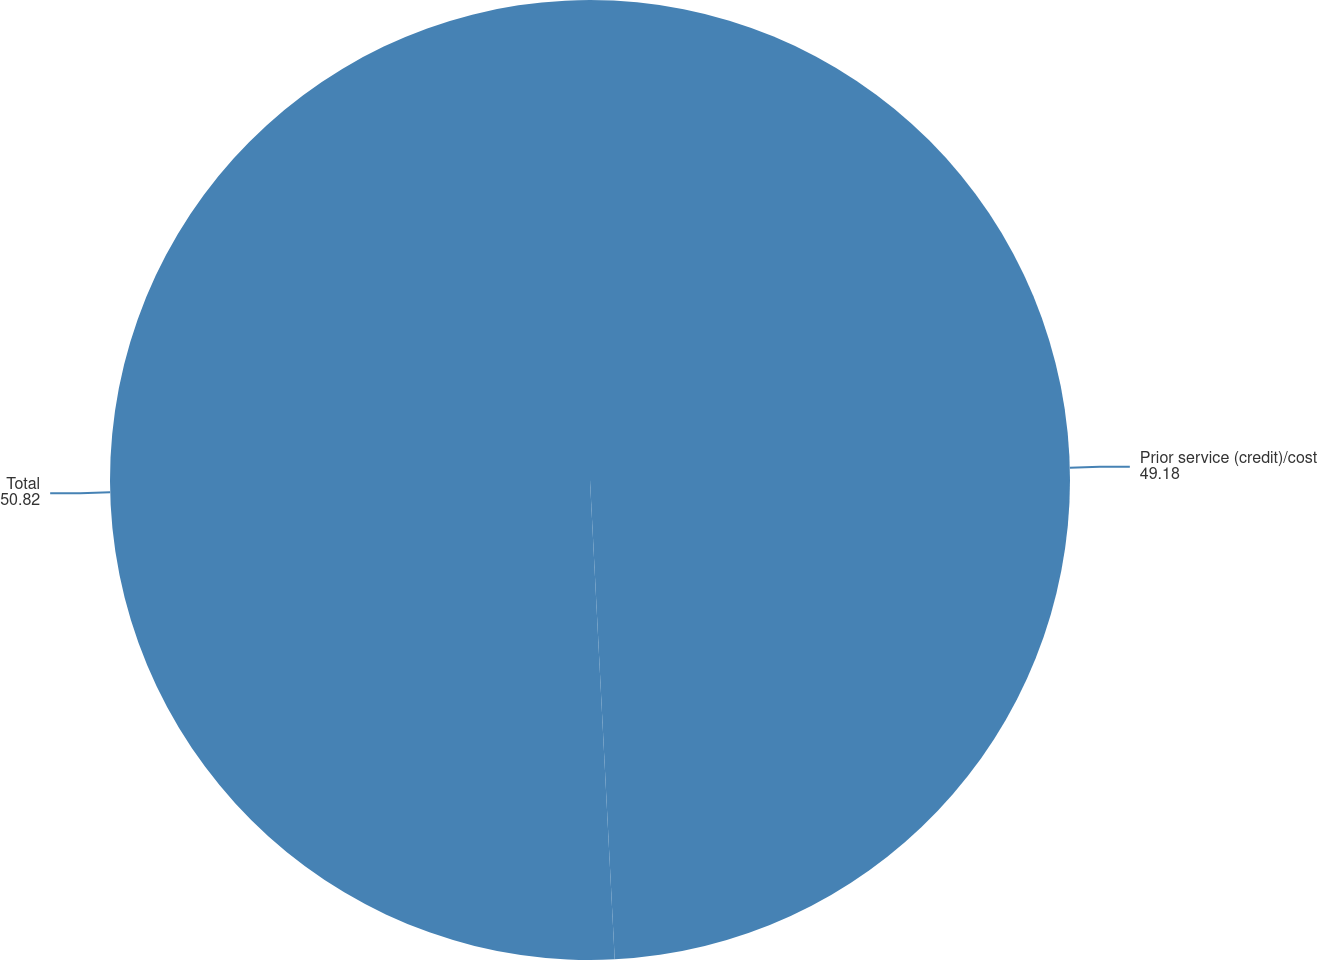Convert chart to OTSL. <chart><loc_0><loc_0><loc_500><loc_500><pie_chart><fcel>Prior service (credit)/cost<fcel>Total<nl><fcel>49.18%<fcel>50.82%<nl></chart> 